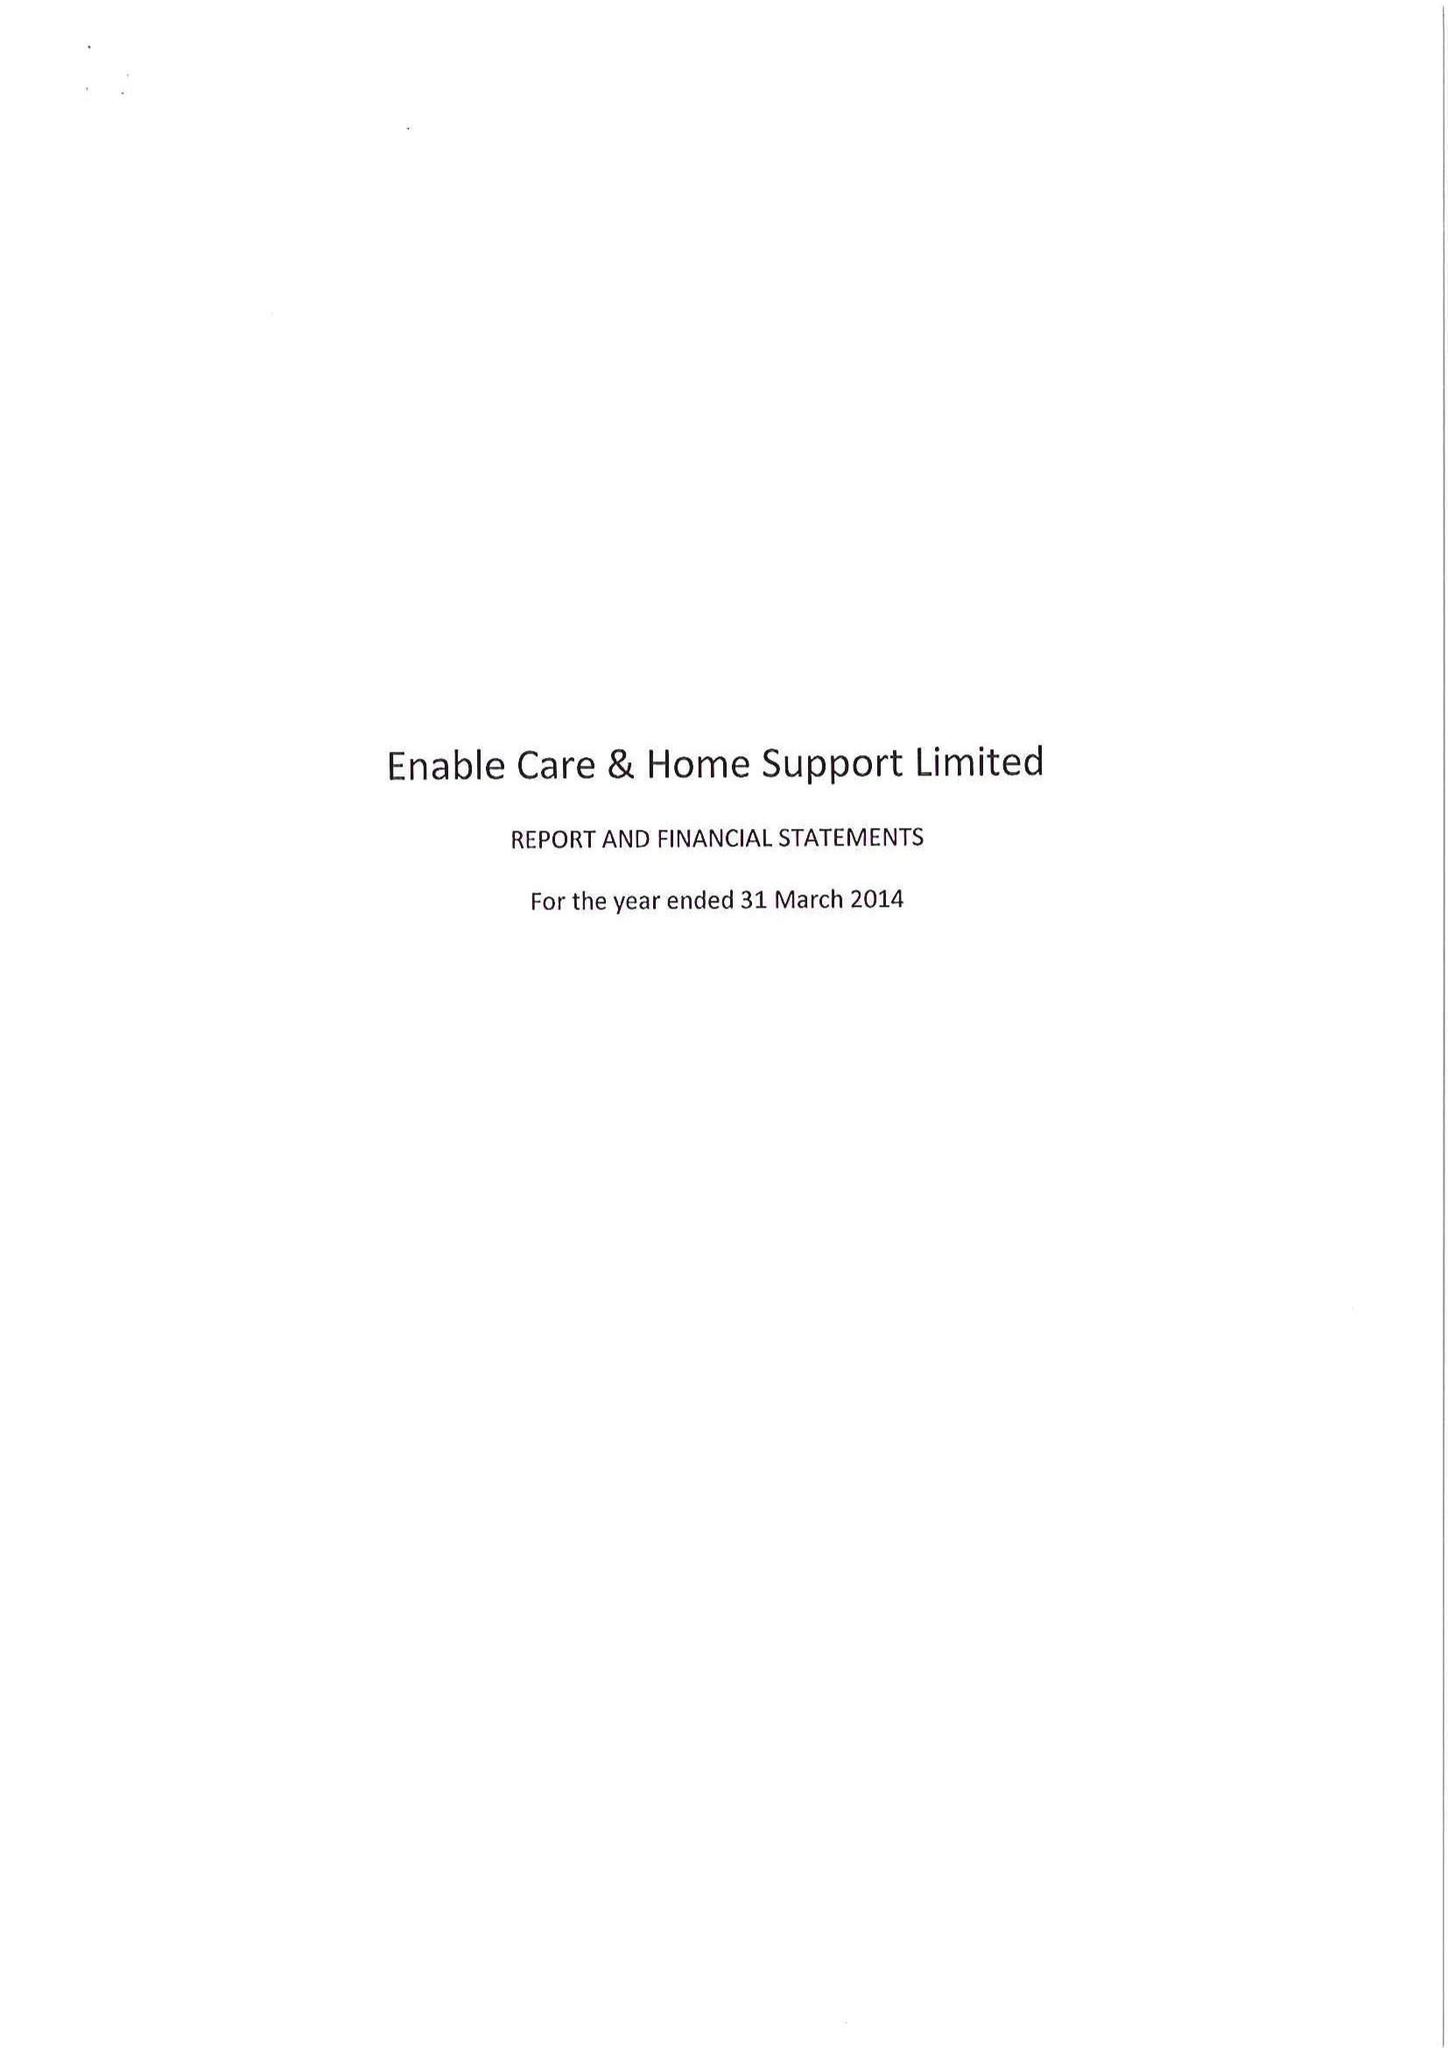What is the value for the address__postcode?
Answer the question using a single word or phrase. LE67 4JP 